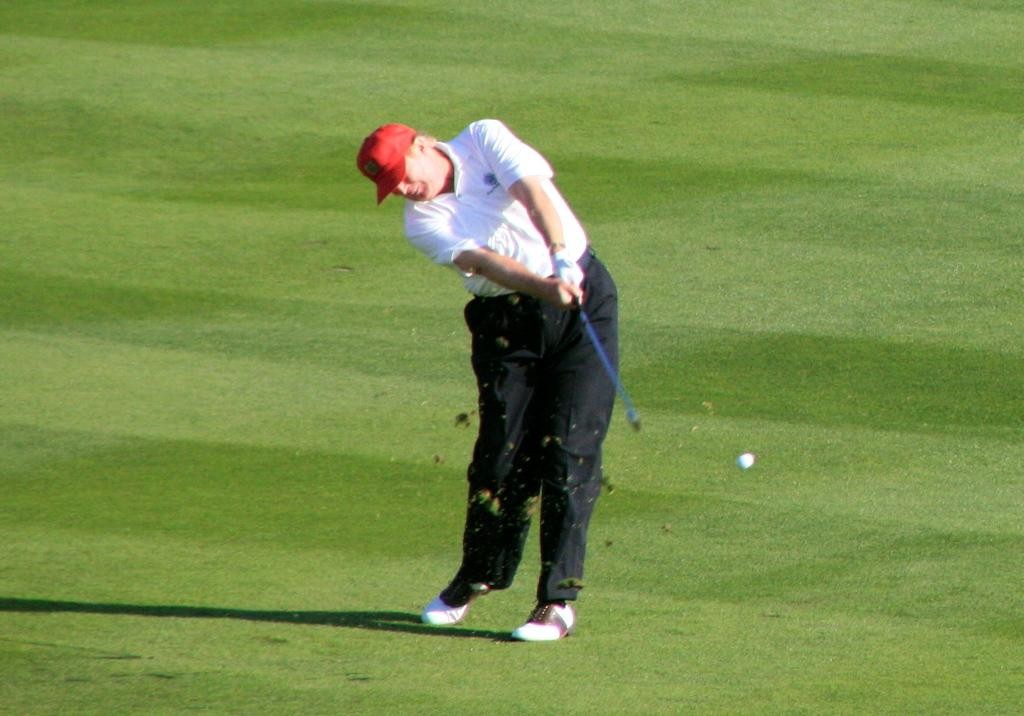Who or what is present in the image? There is a person in the image. What is the person holding? The person is holding an object. What type of surface is visible on the ground? The ground is covered with grass. What other object can be seen in the image? There is a ball in the image. What can be observed on the ground in addition to the grass? There is a shadow on the ground. What type of hair can be seen on the person in the image? There is no information about the person's hair in the provided facts, so we cannot determine the type of hair from the image. What sounds can be heard coming from the downtown area in the image? There is no downtown area or any sounds mentioned in the provided facts, so we cannot determine the sounds from the image. 